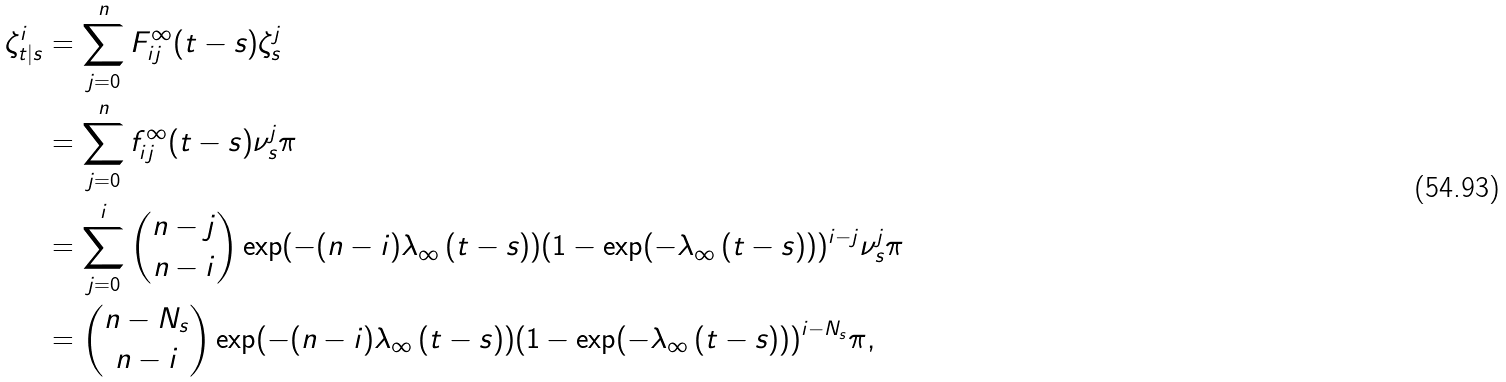<formula> <loc_0><loc_0><loc_500><loc_500>\zeta ^ { i } _ { t | s } & = \sum _ { j = 0 } ^ { n } F ^ { \infty } _ { i j } ( t - s ) \zeta ^ { j } _ { s } \\ & = \sum _ { j = 0 } ^ { n } f ^ { \infty } _ { i j } ( t - s ) \nu ^ { j } _ { s } \pi \\ & = \sum _ { j = 0 } ^ { i } { n - j \choose n - i } \exp ( - ( n - i ) \lambda _ { \infty } \, ( t - s ) ) ( 1 - \exp ( - \lambda _ { \infty } \, ( t - s ) ) ) ^ { i - j } \nu ^ { j } _ { s } \pi \\ & = { n - N _ { s } \choose n - i } \exp ( - ( n - i ) \lambda _ { \infty } \, ( t - s ) ) ( 1 - \exp ( - \lambda _ { \infty } \, ( t - s ) ) ) ^ { i - N _ { s } } \pi ,</formula> 